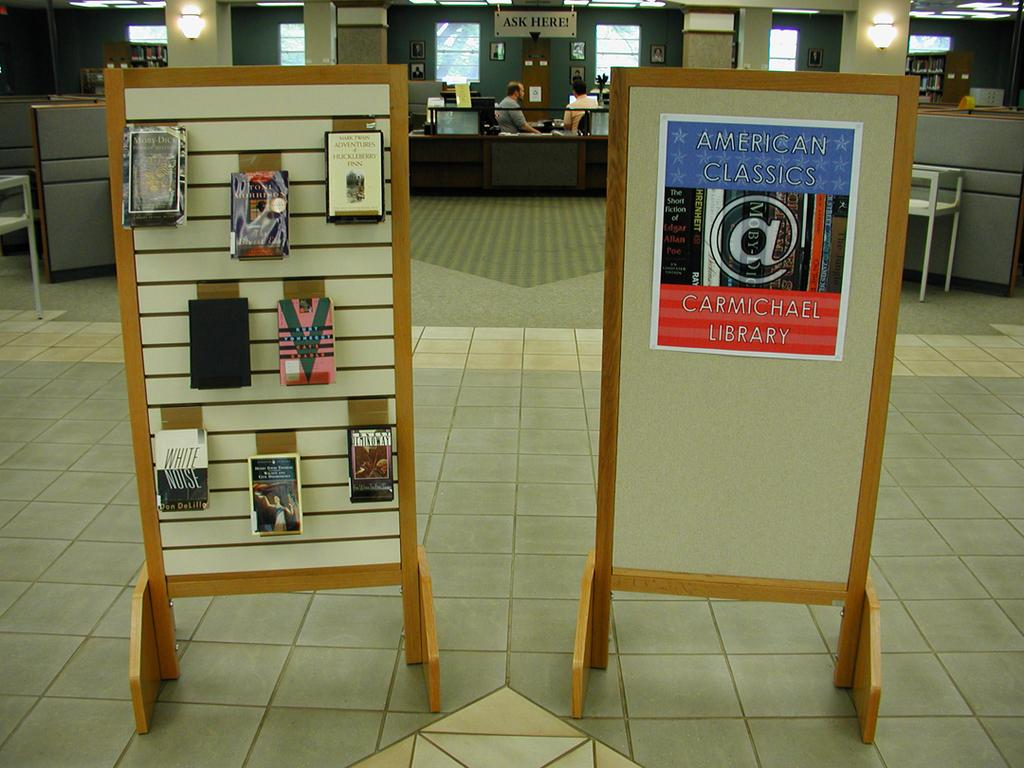<image>
Summarize the visual content of the image. 2 wooden stand up pallets that has American Classics sign Carmichael Library. 